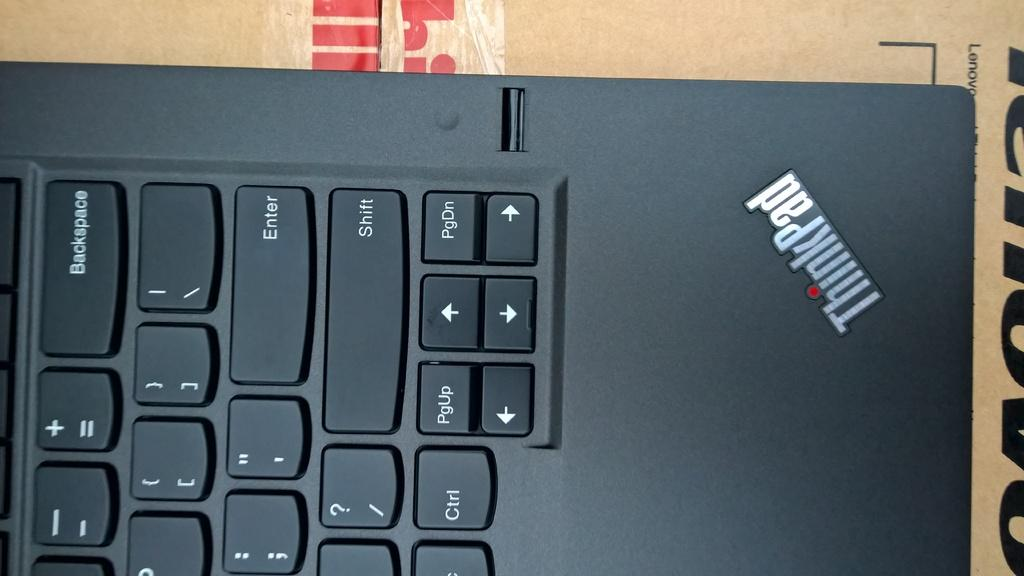<image>
Summarize the visual content of the image. A keyboard has a ThinkPad logo in the corner and sits on top of cardboard. 